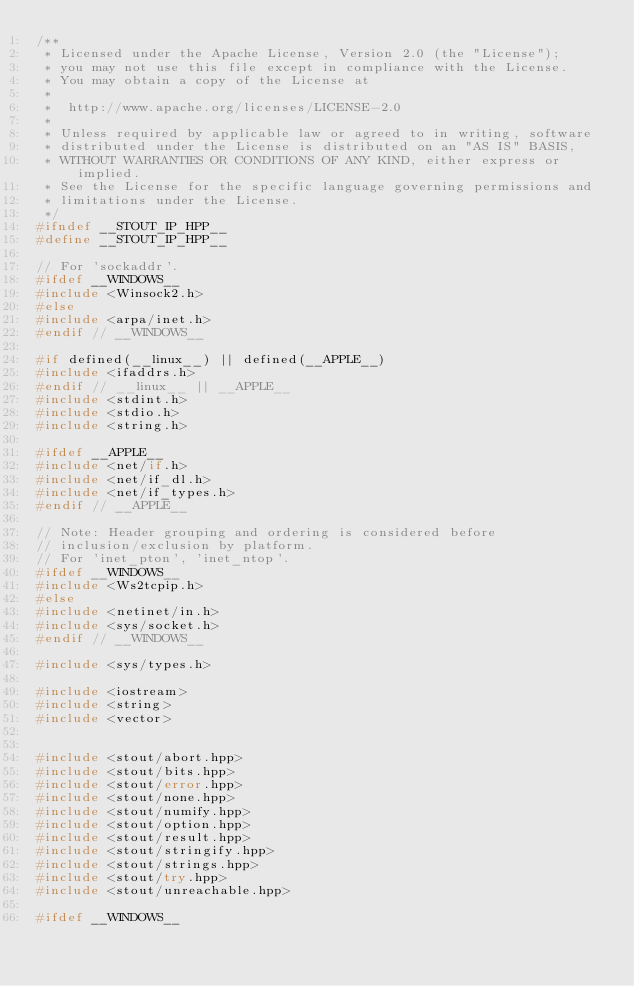<code> <loc_0><loc_0><loc_500><loc_500><_C++_>/**
 * Licensed under the Apache License, Version 2.0 (the "License");
 * you may not use this file except in compliance with the License.
 * You may obtain a copy of the License at
 *
 *  http://www.apache.org/licenses/LICENSE-2.0
 *
 * Unless required by applicable law or agreed to in writing, software
 * distributed under the License is distributed on an "AS IS" BASIS,
 * WITHOUT WARRANTIES OR CONDITIONS OF ANY KIND, either express or implied.
 * See the License for the specific language governing permissions and
 * limitations under the License.
 */
#ifndef __STOUT_IP_HPP__
#define __STOUT_IP_HPP__

// For 'sockaddr'.
#ifdef __WINDOWS__
#include <Winsock2.h>
#else
#include <arpa/inet.h>
#endif // __WINDOWS__

#if defined(__linux__) || defined(__APPLE__)
#include <ifaddrs.h>
#endif // __linux__ || __APPLE__
#include <stdint.h>
#include <stdio.h>
#include <string.h>

#ifdef __APPLE__
#include <net/if.h>
#include <net/if_dl.h>
#include <net/if_types.h>
#endif // __APPLE__

// Note: Header grouping and ordering is considered before
// inclusion/exclusion by platform.
// For 'inet_pton', 'inet_ntop'.
#ifdef __WINDOWS__
#include <Ws2tcpip.h>
#else
#include <netinet/in.h>
#include <sys/socket.h>
#endif // __WINDOWS__

#include <sys/types.h>

#include <iostream>
#include <string>
#include <vector>


#include <stout/abort.hpp>
#include <stout/bits.hpp>
#include <stout/error.hpp>
#include <stout/none.hpp>
#include <stout/numify.hpp>
#include <stout/option.hpp>
#include <stout/result.hpp>
#include <stout/stringify.hpp>
#include <stout/strings.hpp>
#include <stout/try.hpp>
#include <stout/unreachable.hpp>

#ifdef __WINDOWS__</code> 